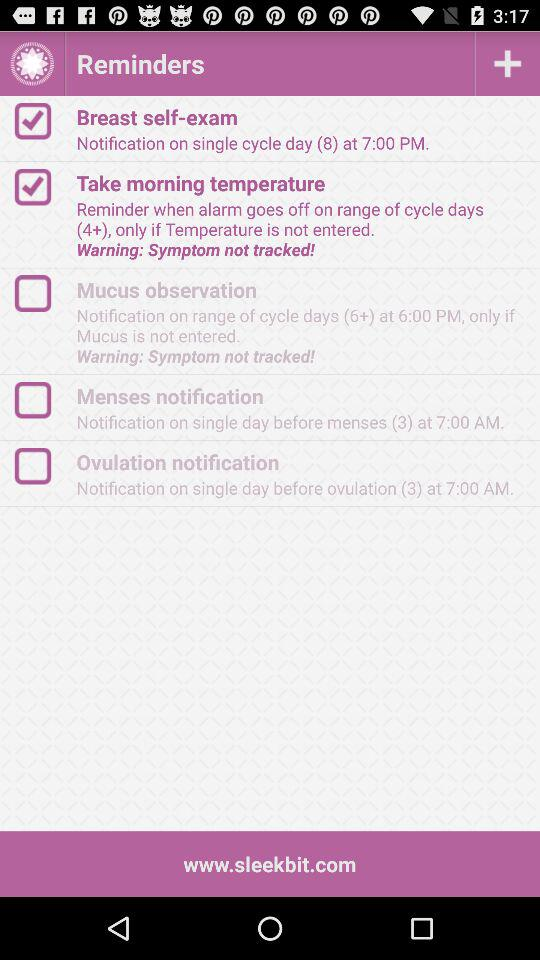What is the time of the notification for "Breast self-exam"? The time of the notification for "Breast self-exam" is 7:00 PM. 